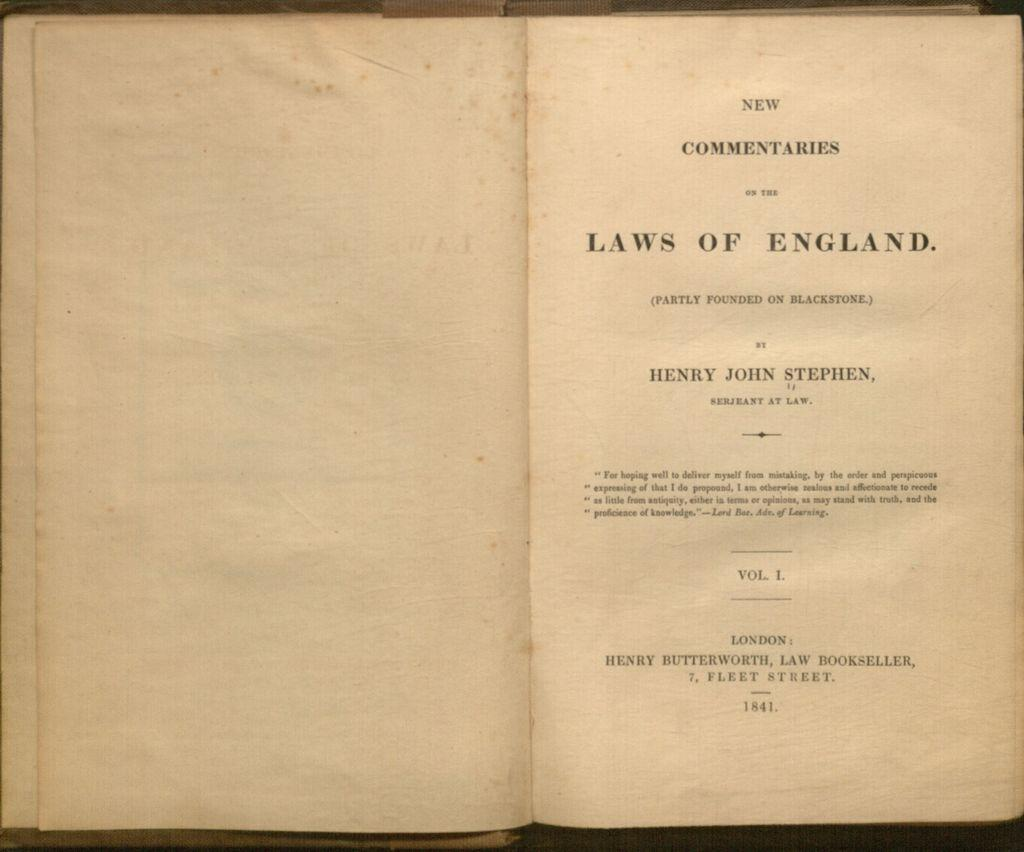<image>
Summarize the visual content of the image. An opened book showing the title page of New Commentaries on the Laws of England, by Henry John Stephen. 